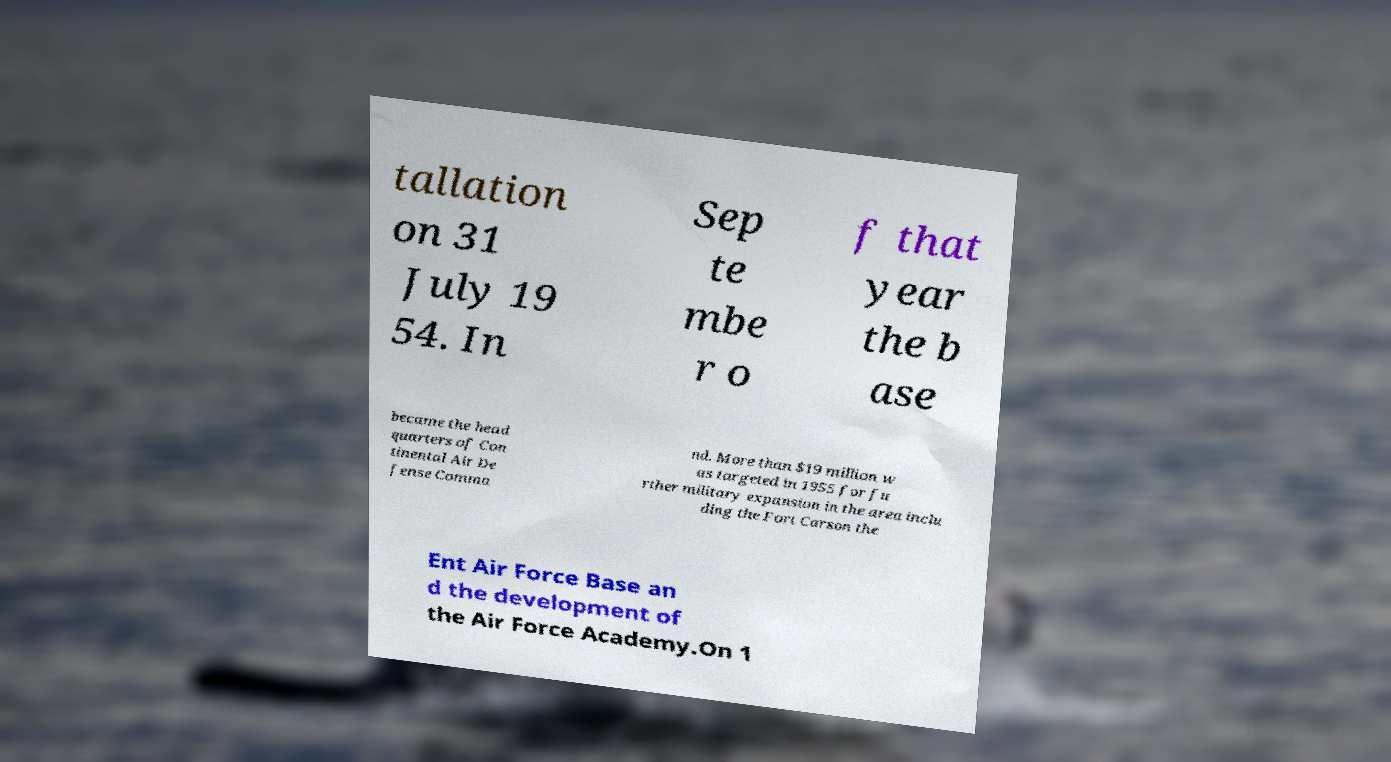Could you extract and type out the text from this image? tallation on 31 July 19 54. In Sep te mbe r o f that year the b ase became the head quarters of Con tinental Air De fense Comma nd. More than $19 million w as targeted in 1955 for fu rther military expansion in the area inclu ding the Fort Carson the Ent Air Force Base an d the development of the Air Force Academy.On 1 